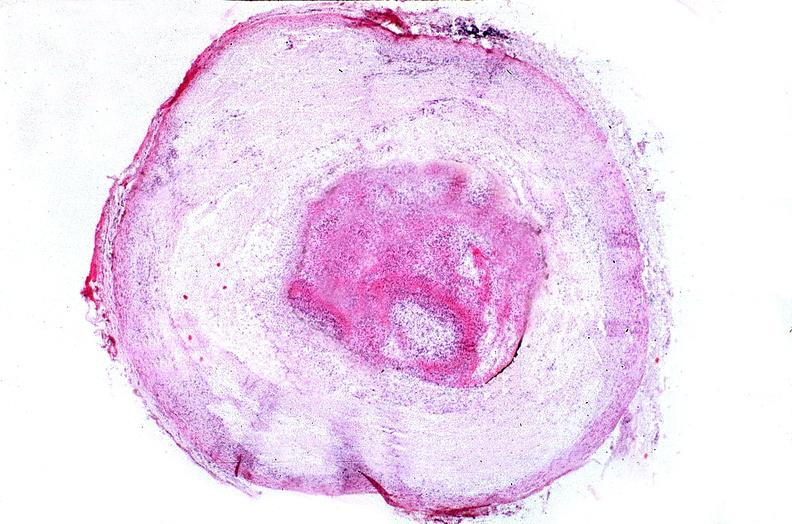s cardiovascular present?
Answer the question using a single word or phrase. Yes 